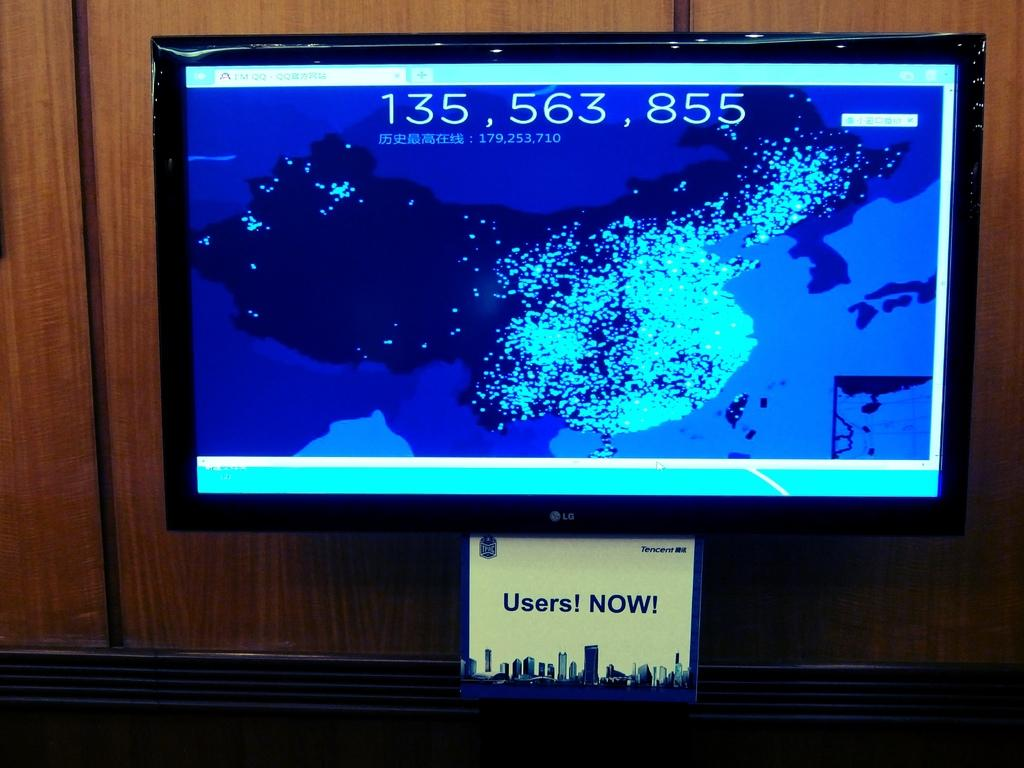<image>
Write a terse but informative summary of the picture. the number 135 that is on a television screen 